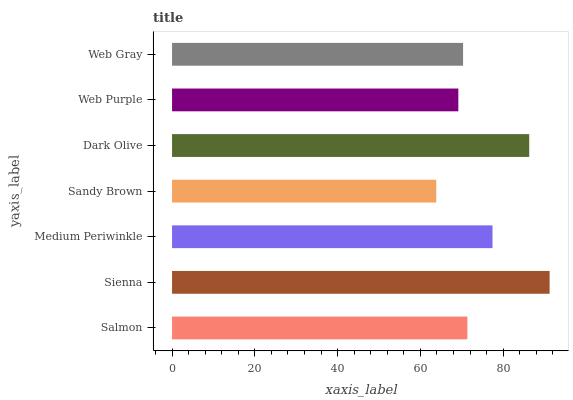Is Sandy Brown the minimum?
Answer yes or no. Yes. Is Sienna the maximum?
Answer yes or no. Yes. Is Medium Periwinkle the minimum?
Answer yes or no. No. Is Medium Periwinkle the maximum?
Answer yes or no. No. Is Sienna greater than Medium Periwinkle?
Answer yes or no. Yes. Is Medium Periwinkle less than Sienna?
Answer yes or no. Yes. Is Medium Periwinkle greater than Sienna?
Answer yes or no. No. Is Sienna less than Medium Periwinkle?
Answer yes or no. No. Is Salmon the high median?
Answer yes or no. Yes. Is Salmon the low median?
Answer yes or no. Yes. Is Sandy Brown the high median?
Answer yes or no. No. Is Web Purple the low median?
Answer yes or no. No. 